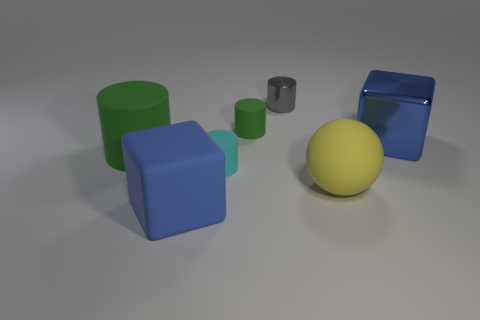There is a cyan cylinder that is the same size as the gray cylinder; what is it made of?
Provide a short and direct response. Rubber. Is there a purple sphere of the same size as the metal cylinder?
Offer a very short reply. No. Does the tiny green matte object have the same shape as the cyan rubber thing?
Make the answer very short. Yes. Is there a blue cube on the left side of the green thing in front of the blue cube right of the gray metallic thing?
Your answer should be compact. No. What number of other objects are the same color as the tiny metallic cylinder?
Give a very brief answer. 0. Does the blue block to the left of the small metallic object have the same size as the blue cube that is right of the yellow rubber thing?
Offer a terse response. Yes. Are there the same number of tiny gray metal cylinders that are in front of the tiny gray object and big cubes on the left side of the cyan rubber cylinder?
Your response must be concise. No. Is there any other thing that is made of the same material as the large green cylinder?
Offer a very short reply. Yes. There is a gray cylinder; is its size the same as the green object that is on the left side of the large rubber cube?
Offer a terse response. No. What material is the blue block in front of the shiny thing in front of the gray thing made of?
Ensure brevity in your answer.  Rubber. 